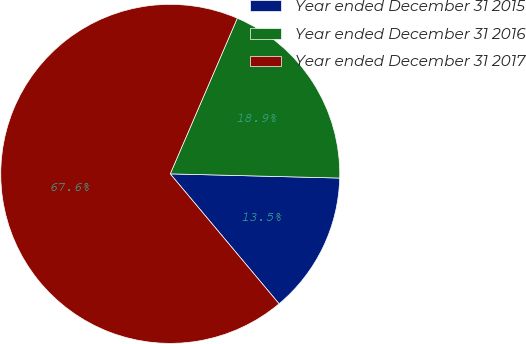<chart> <loc_0><loc_0><loc_500><loc_500><pie_chart><fcel>Year ended December 31 2015<fcel>Year ended December 31 2016<fcel>Year ended December 31 2017<nl><fcel>13.51%<fcel>18.92%<fcel>67.57%<nl></chart> 